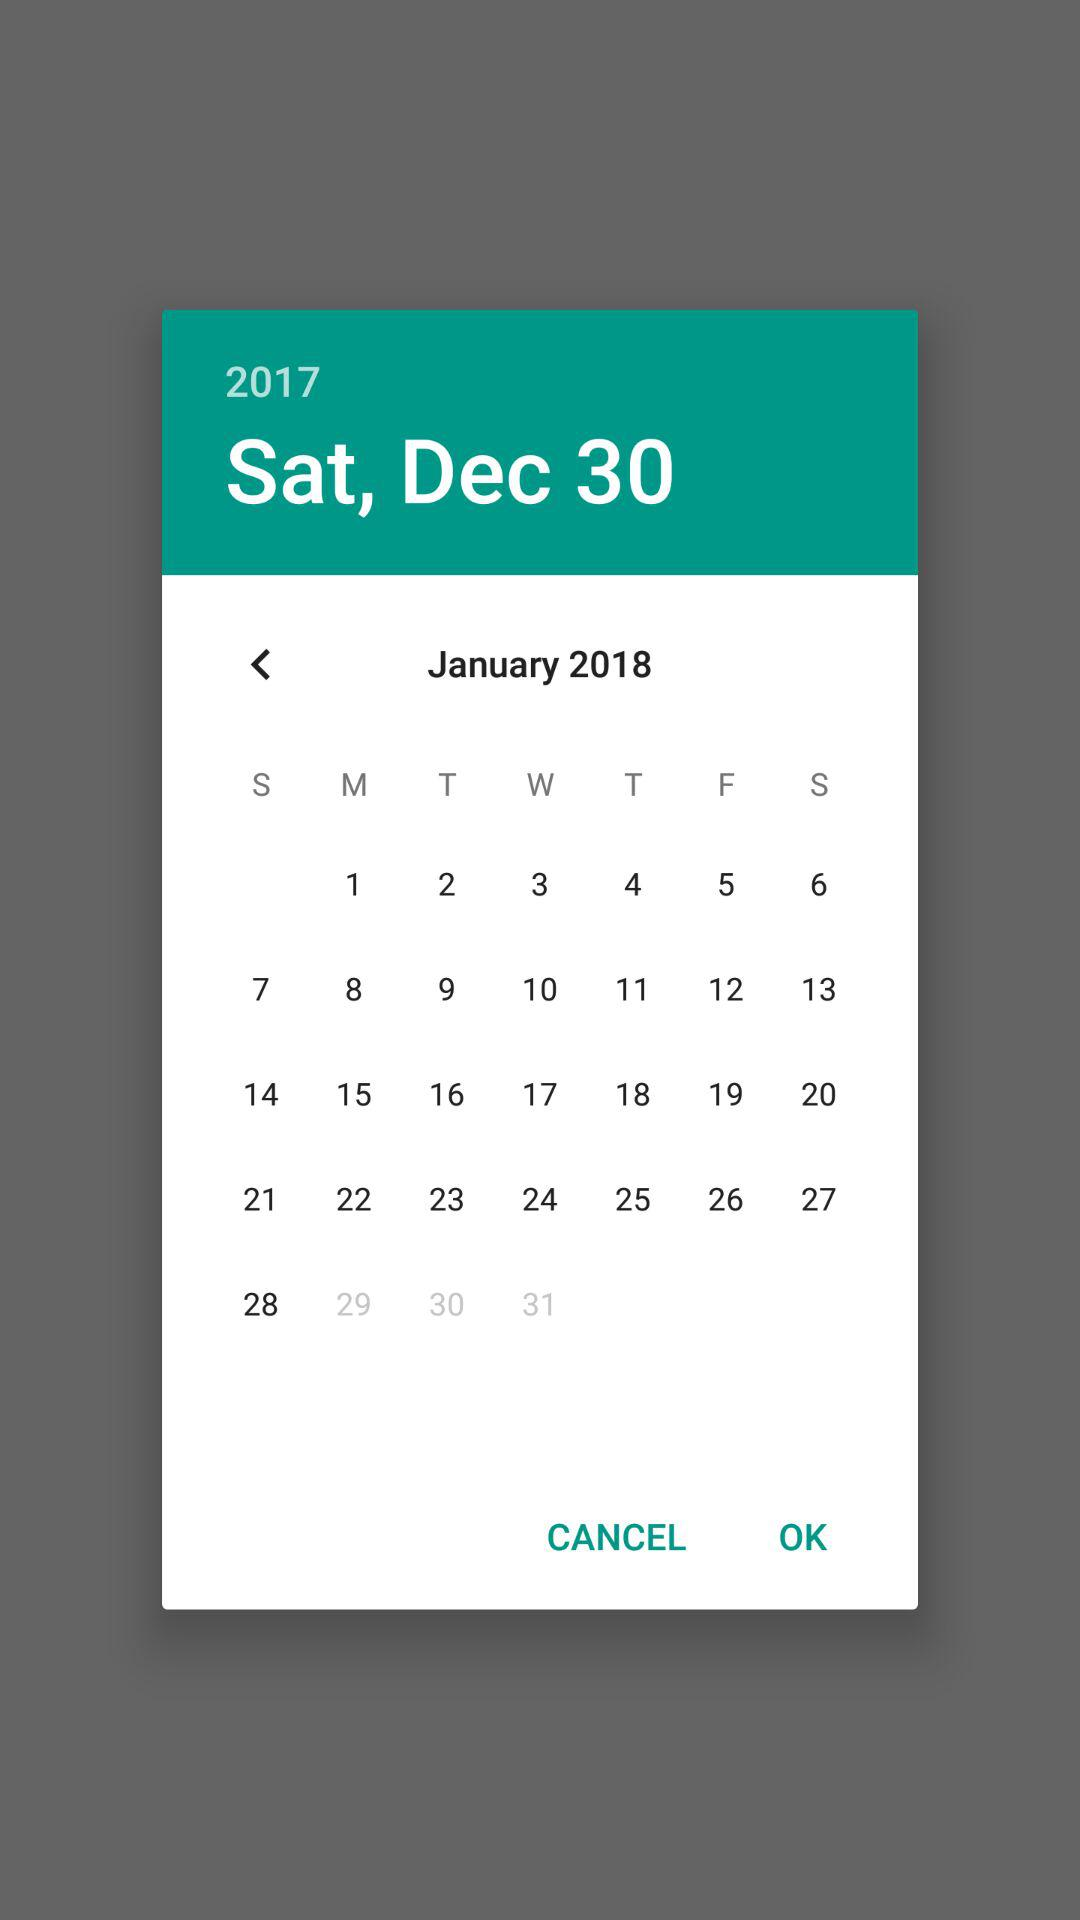What is the date? The date is Saturday, December 30, 2017. 